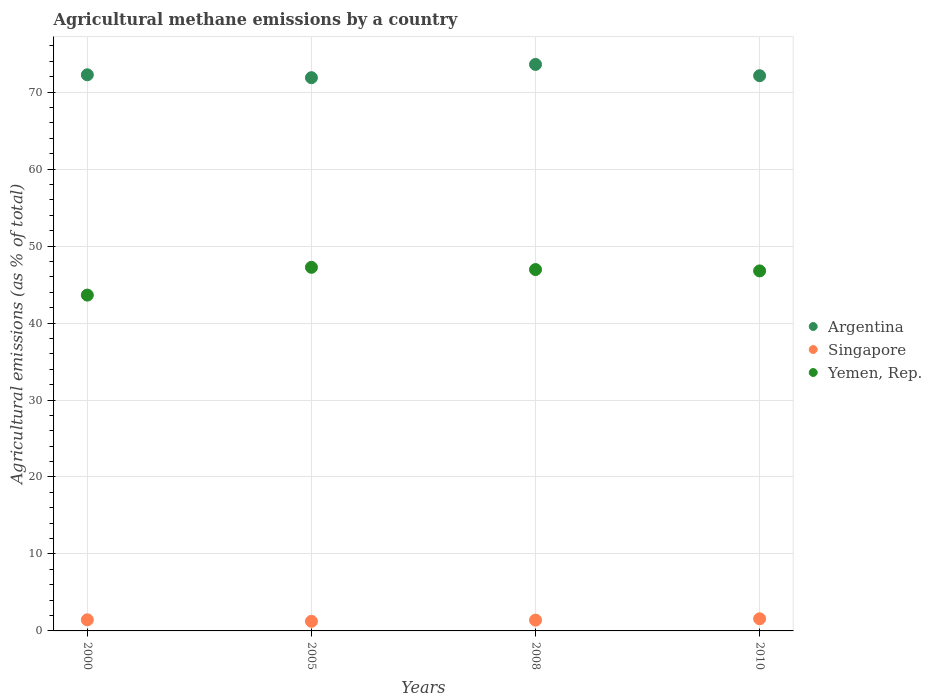How many different coloured dotlines are there?
Your answer should be very brief. 3. What is the amount of agricultural methane emitted in Singapore in 2008?
Provide a short and direct response. 1.4. Across all years, what is the maximum amount of agricultural methane emitted in Yemen, Rep.?
Keep it short and to the point. 47.24. Across all years, what is the minimum amount of agricultural methane emitted in Singapore?
Give a very brief answer. 1.25. In which year was the amount of agricultural methane emitted in Yemen, Rep. maximum?
Give a very brief answer. 2005. In which year was the amount of agricultural methane emitted in Yemen, Rep. minimum?
Keep it short and to the point. 2000. What is the total amount of agricultural methane emitted in Yemen, Rep. in the graph?
Your response must be concise. 184.61. What is the difference between the amount of agricultural methane emitted in Yemen, Rep. in 2000 and that in 2005?
Your answer should be compact. -3.61. What is the difference between the amount of agricultural methane emitted in Argentina in 2000 and the amount of agricultural methane emitted in Singapore in 2005?
Provide a short and direct response. 71.01. What is the average amount of agricultural methane emitted in Singapore per year?
Provide a succinct answer. 1.42. In the year 2010, what is the difference between the amount of agricultural methane emitted in Singapore and amount of agricultural methane emitted in Argentina?
Your response must be concise. -70.56. In how many years, is the amount of agricultural methane emitted in Yemen, Rep. greater than 72 %?
Keep it short and to the point. 0. What is the ratio of the amount of agricultural methane emitted in Singapore in 2008 to that in 2010?
Offer a terse response. 0.89. Is the amount of agricultural methane emitted in Yemen, Rep. in 2000 less than that in 2005?
Offer a terse response. Yes. What is the difference between the highest and the second highest amount of agricultural methane emitted in Argentina?
Provide a succinct answer. 1.35. What is the difference between the highest and the lowest amount of agricultural methane emitted in Yemen, Rep.?
Provide a short and direct response. 3.61. In how many years, is the amount of agricultural methane emitted in Yemen, Rep. greater than the average amount of agricultural methane emitted in Yemen, Rep. taken over all years?
Provide a succinct answer. 3. Is it the case that in every year, the sum of the amount of agricultural methane emitted in Yemen, Rep. and amount of agricultural methane emitted in Singapore  is greater than the amount of agricultural methane emitted in Argentina?
Keep it short and to the point. No. Is the amount of agricultural methane emitted in Singapore strictly less than the amount of agricultural methane emitted in Yemen, Rep. over the years?
Offer a very short reply. Yes. How many dotlines are there?
Your answer should be very brief. 3. How many years are there in the graph?
Give a very brief answer. 4. Are the values on the major ticks of Y-axis written in scientific E-notation?
Provide a short and direct response. No. How many legend labels are there?
Provide a succinct answer. 3. How are the legend labels stacked?
Provide a short and direct response. Vertical. What is the title of the graph?
Ensure brevity in your answer.  Agricultural methane emissions by a country. What is the label or title of the Y-axis?
Your answer should be compact. Agricultural emissions (as % of total). What is the Agricultural emissions (as % of total) of Argentina in 2000?
Make the answer very short. 72.26. What is the Agricultural emissions (as % of total) in Singapore in 2000?
Give a very brief answer. 1.44. What is the Agricultural emissions (as % of total) of Yemen, Rep. in 2000?
Give a very brief answer. 43.64. What is the Agricultural emissions (as % of total) of Argentina in 2005?
Provide a short and direct response. 71.88. What is the Agricultural emissions (as % of total) in Singapore in 2005?
Ensure brevity in your answer.  1.25. What is the Agricultural emissions (as % of total) of Yemen, Rep. in 2005?
Your response must be concise. 47.24. What is the Agricultural emissions (as % of total) of Argentina in 2008?
Your answer should be compact. 73.61. What is the Agricultural emissions (as % of total) of Singapore in 2008?
Make the answer very short. 1.4. What is the Agricultural emissions (as % of total) in Yemen, Rep. in 2008?
Offer a very short reply. 46.95. What is the Agricultural emissions (as % of total) in Argentina in 2010?
Offer a very short reply. 72.14. What is the Agricultural emissions (as % of total) of Singapore in 2010?
Keep it short and to the point. 1.58. What is the Agricultural emissions (as % of total) in Yemen, Rep. in 2010?
Ensure brevity in your answer.  46.78. Across all years, what is the maximum Agricultural emissions (as % of total) in Argentina?
Give a very brief answer. 73.61. Across all years, what is the maximum Agricultural emissions (as % of total) of Singapore?
Provide a succinct answer. 1.58. Across all years, what is the maximum Agricultural emissions (as % of total) in Yemen, Rep.?
Your answer should be very brief. 47.24. Across all years, what is the minimum Agricultural emissions (as % of total) of Argentina?
Give a very brief answer. 71.88. Across all years, what is the minimum Agricultural emissions (as % of total) in Singapore?
Ensure brevity in your answer.  1.25. Across all years, what is the minimum Agricultural emissions (as % of total) of Yemen, Rep.?
Ensure brevity in your answer.  43.64. What is the total Agricultural emissions (as % of total) of Argentina in the graph?
Your answer should be very brief. 289.89. What is the total Agricultural emissions (as % of total) in Singapore in the graph?
Your response must be concise. 5.67. What is the total Agricultural emissions (as % of total) in Yemen, Rep. in the graph?
Make the answer very short. 184.61. What is the difference between the Agricultural emissions (as % of total) in Argentina in 2000 and that in 2005?
Offer a very short reply. 0.38. What is the difference between the Agricultural emissions (as % of total) in Singapore in 2000 and that in 2005?
Offer a very short reply. 0.2. What is the difference between the Agricultural emissions (as % of total) of Yemen, Rep. in 2000 and that in 2005?
Provide a succinct answer. -3.61. What is the difference between the Agricultural emissions (as % of total) of Argentina in 2000 and that in 2008?
Your response must be concise. -1.35. What is the difference between the Agricultural emissions (as % of total) of Singapore in 2000 and that in 2008?
Provide a short and direct response. 0.04. What is the difference between the Agricultural emissions (as % of total) in Yemen, Rep. in 2000 and that in 2008?
Provide a succinct answer. -3.32. What is the difference between the Agricultural emissions (as % of total) in Argentina in 2000 and that in 2010?
Make the answer very short. 0.12. What is the difference between the Agricultural emissions (as % of total) of Singapore in 2000 and that in 2010?
Ensure brevity in your answer.  -0.13. What is the difference between the Agricultural emissions (as % of total) of Yemen, Rep. in 2000 and that in 2010?
Provide a succinct answer. -3.14. What is the difference between the Agricultural emissions (as % of total) in Argentina in 2005 and that in 2008?
Offer a very short reply. -1.72. What is the difference between the Agricultural emissions (as % of total) in Singapore in 2005 and that in 2008?
Offer a very short reply. -0.15. What is the difference between the Agricultural emissions (as % of total) in Yemen, Rep. in 2005 and that in 2008?
Give a very brief answer. 0.29. What is the difference between the Agricultural emissions (as % of total) of Argentina in 2005 and that in 2010?
Provide a short and direct response. -0.26. What is the difference between the Agricultural emissions (as % of total) of Singapore in 2005 and that in 2010?
Your response must be concise. -0.33. What is the difference between the Agricultural emissions (as % of total) of Yemen, Rep. in 2005 and that in 2010?
Offer a very short reply. 0.46. What is the difference between the Agricultural emissions (as % of total) of Argentina in 2008 and that in 2010?
Your response must be concise. 1.47. What is the difference between the Agricultural emissions (as % of total) of Singapore in 2008 and that in 2010?
Provide a succinct answer. -0.18. What is the difference between the Agricultural emissions (as % of total) in Yemen, Rep. in 2008 and that in 2010?
Your answer should be compact. 0.18. What is the difference between the Agricultural emissions (as % of total) in Argentina in 2000 and the Agricultural emissions (as % of total) in Singapore in 2005?
Your response must be concise. 71.01. What is the difference between the Agricultural emissions (as % of total) of Argentina in 2000 and the Agricultural emissions (as % of total) of Yemen, Rep. in 2005?
Make the answer very short. 25.02. What is the difference between the Agricultural emissions (as % of total) in Singapore in 2000 and the Agricultural emissions (as % of total) in Yemen, Rep. in 2005?
Your answer should be very brief. -45.8. What is the difference between the Agricultural emissions (as % of total) of Argentina in 2000 and the Agricultural emissions (as % of total) of Singapore in 2008?
Your answer should be very brief. 70.86. What is the difference between the Agricultural emissions (as % of total) in Argentina in 2000 and the Agricultural emissions (as % of total) in Yemen, Rep. in 2008?
Your answer should be compact. 25.31. What is the difference between the Agricultural emissions (as % of total) in Singapore in 2000 and the Agricultural emissions (as % of total) in Yemen, Rep. in 2008?
Offer a terse response. -45.51. What is the difference between the Agricultural emissions (as % of total) of Argentina in 2000 and the Agricultural emissions (as % of total) of Singapore in 2010?
Your answer should be very brief. 70.68. What is the difference between the Agricultural emissions (as % of total) in Argentina in 2000 and the Agricultural emissions (as % of total) in Yemen, Rep. in 2010?
Ensure brevity in your answer.  25.48. What is the difference between the Agricultural emissions (as % of total) in Singapore in 2000 and the Agricultural emissions (as % of total) in Yemen, Rep. in 2010?
Provide a succinct answer. -45.33. What is the difference between the Agricultural emissions (as % of total) of Argentina in 2005 and the Agricultural emissions (as % of total) of Singapore in 2008?
Offer a terse response. 70.48. What is the difference between the Agricultural emissions (as % of total) in Argentina in 2005 and the Agricultural emissions (as % of total) in Yemen, Rep. in 2008?
Ensure brevity in your answer.  24.93. What is the difference between the Agricultural emissions (as % of total) in Singapore in 2005 and the Agricultural emissions (as % of total) in Yemen, Rep. in 2008?
Provide a succinct answer. -45.71. What is the difference between the Agricultural emissions (as % of total) of Argentina in 2005 and the Agricultural emissions (as % of total) of Singapore in 2010?
Your answer should be compact. 70.31. What is the difference between the Agricultural emissions (as % of total) in Argentina in 2005 and the Agricultural emissions (as % of total) in Yemen, Rep. in 2010?
Make the answer very short. 25.11. What is the difference between the Agricultural emissions (as % of total) of Singapore in 2005 and the Agricultural emissions (as % of total) of Yemen, Rep. in 2010?
Your answer should be compact. -45.53. What is the difference between the Agricultural emissions (as % of total) of Argentina in 2008 and the Agricultural emissions (as % of total) of Singapore in 2010?
Your response must be concise. 72.03. What is the difference between the Agricultural emissions (as % of total) of Argentina in 2008 and the Agricultural emissions (as % of total) of Yemen, Rep. in 2010?
Make the answer very short. 26.83. What is the difference between the Agricultural emissions (as % of total) of Singapore in 2008 and the Agricultural emissions (as % of total) of Yemen, Rep. in 2010?
Offer a very short reply. -45.38. What is the average Agricultural emissions (as % of total) in Argentina per year?
Ensure brevity in your answer.  72.47. What is the average Agricultural emissions (as % of total) of Singapore per year?
Make the answer very short. 1.42. What is the average Agricultural emissions (as % of total) of Yemen, Rep. per year?
Offer a very short reply. 46.15. In the year 2000, what is the difference between the Agricultural emissions (as % of total) of Argentina and Agricultural emissions (as % of total) of Singapore?
Ensure brevity in your answer.  70.82. In the year 2000, what is the difference between the Agricultural emissions (as % of total) of Argentina and Agricultural emissions (as % of total) of Yemen, Rep.?
Offer a terse response. 28.62. In the year 2000, what is the difference between the Agricultural emissions (as % of total) of Singapore and Agricultural emissions (as % of total) of Yemen, Rep.?
Your answer should be compact. -42.19. In the year 2005, what is the difference between the Agricultural emissions (as % of total) in Argentina and Agricultural emissions (as % of total) in Singapore?
Offer a very short reply. 70.64. In the year 2005, what is the difference between the Agricultural emissions (as % of total) in Argentina and Agricultural emissions (as % of total) in Yemen, Rep.?
Offer a very short reply. 24.64. In the year 2005, what is the difference between the Agricultural emissions (as % of total) of Singapore and Agricultural emissions (as % of total) of Yemen, Rep.?
Offer a terse response. -45.99. In the year 2008, what is the difference between the Agricultural emissions (as % of total) of Argentina and Agricultural emissions (as % of total) of Singapore?
Your answer should be compact. 72.2. In the year 2008, what is the difference between the Agricultural emissions (as % of total) in Argentina and Agricultural emissions (as % of total) in Yemen, Rep.?
Provide a succinct answer. 26.65. In the year 2008, what is the difference between the Agricultural emissions (as % of total) of Singapore and Agricultural emissions (as % of total) of Yemen, Rep.?
Give a very brief answer. -45.55. In the year 2010, what is the difference between the Agricultural emissions (as % of total) of Argentina and Agricultural emissions (as % of total) of Singapore?
Your answer should be compact. 70.56. In the year 2010, what is the difference between the Agricultural emissions (as % of total) in Argentina and Agricultural emissions (as % of total) in Yemen, Rep.?
Your answer should be compact. 25.36. In the year 2010, what is the difference between the Agricultural emissions (as % of total) of Singapore and Agricultural emissions (as % of total) of Yemen, Rep.?
Offer a very short reply. -45.2. What is the ratio of the Agricultural emissions (as % of total) of Singapore in 2000 to that in 2005?
Ensure brevity in your answer.  1.16. What is the ratio of the Agricultural emissions (as % of total) in Yemen, Rep. in 2000 to that in 2005?
Make the answer very short. 0.92. What is the ratio of the Agricultural emissions (as % of total) in Argentina in 2000 to that in 2008?
Offer a very short reply. 0.98. What is the ratio of the Agricultural emissions (as % of total) in Singapore in 2000 to that in 2008?
Give a very brief answer. 1.03. What is the ratio of the Agricultural emissions (as % of total) in Yemen, Rep. in 2000 to that in 2008?
Keep it short and to the point. 0.93. What is the ratio of the Agricultural emissions (as % of total) in Argentina in 2000 to that in 2010?
Offer a very short reply. 1. What is the ratio of the Agricultural emissions (as % of total) of Singapore in 2000 to that in 2010?
Your response must be concise. 0.91. What is the ratio of the Agricultural emissions (as % of total) of Yemen, Rep. in 2000 to that in 2010?
Provide a short and direct response. 0.93. What is the ratio of the Agricultural emissions (as % of total) of Argentina in 2005 to that in 2008?
Provide a succinct answer. 0.98. What is the ratio of the Agricultural emissions (as % of total) in Singapore in 2005 to that in 2008?
Offer a very short reply. 0.89. What is the ratio of the Agricultural emissions (as % of total) of Yemen, Rep. in 2005 to that in 2008?
Offer a very short reply. 1.01. What is the ratio of the Agricultural emissions (as % of total) in Argentina in 2005 to that in 2010?
Offer a terse response. 1. What is the ratio of the Agricultural emissions (as % of total) of Singapore in 2005 to that in 2010?
Give a very brief answer. 0.79. What is the ratio of the Agricultural emissions (as % of total) in Yemen, Rep. in 2005 to that in 2010?
Give a very brief answer. 1.01. What is the ratio of the Agricultural emissions (as % of total) of Argentina in 2008 to that in 2010?
Make the answer very short. 1.02. What is the ratio of the Agricultural emissions (as % of total) of Singapore in 2008 to that in 2010?
Keep it short and to the point. 0.89. What is the ratio of the Agricultural emissions (as % of total) in Yemen, Rep. in 2008 to that in 2010?
Provide a short and direct response. 1. What is the difference between the highest and the second highest Agricultural emissions (as % of total) in Argentina?
Your answer should be very brief. 1.35. What is the difference between the highest and the second highest Agricultural emissions (as % of total) of Singapore?
Your answer should be compact. 0.13. What is the difference between the highest and the second highest Agricultural emissions (as % of total) of Yemen, Rep.?
Make the answer very short. 0.29. What is the difference between the highest and the lowest Agricultural emissions (as % of total) of Argentina?
Your answer should be very brief. 1.72. What is the difference between the highest and the lowest Agricultural emissions (as % of total) of Singapore?
Make the answer very short. 0.33. What is the difference between the highest and the lowest Agricultural emissions (as % of total) of Yemen, Rep.?
Give a very brief answer. 3.61. 